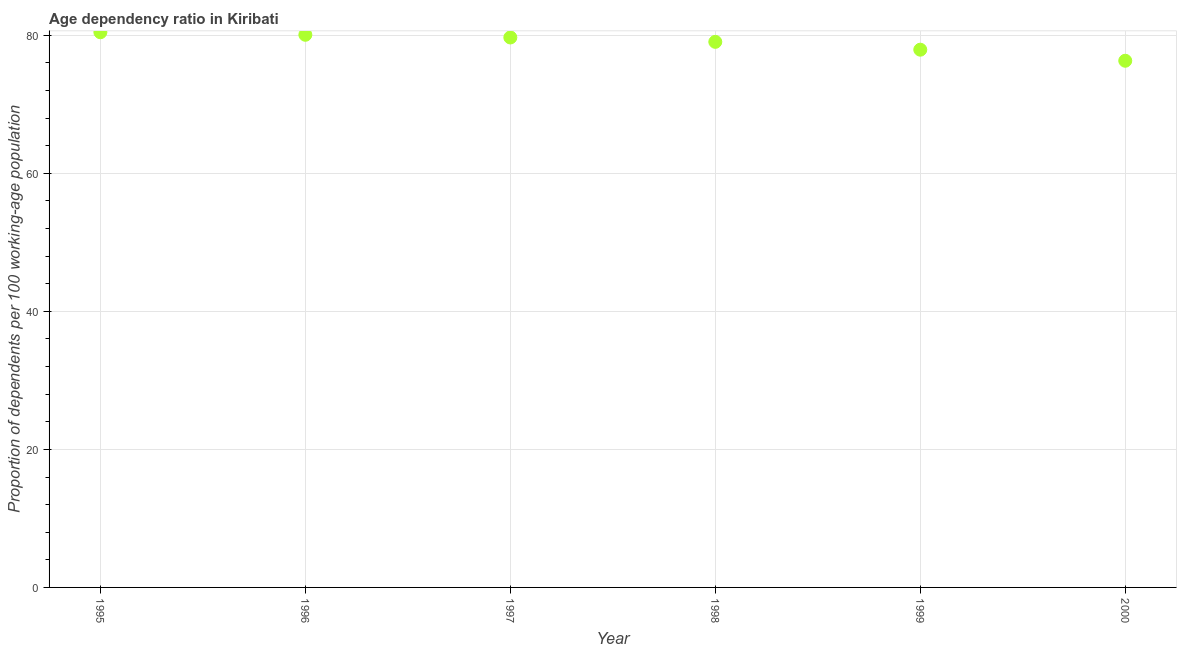What is the age dependency ratio in 1999?
Make the answer very short. 77.92. Across all years, what is the maximum age dependency ratio?
Give a very brief answer. 80.45. Across all years, what is the minimum age dependency ratio?
Provide a succinct answer. 76.32. In which year was the age dependency ratio maximum?
Make the answer very short. 1995. What is the sum of the age dependency ratio?
Offer a terse response. 473.5. What is the difference between the age dependency ratio in 1997 and 1998?
Provide a short and direct response. 0.63. What is the average age dependency ratio per year?
Offer a very short reply. 78.92. What is the median age dependency ratio?
Your response must be concise. 79.37. In how many years, is the age dependency ratio greater than 44 ?
Give a very brief answer. 6. What is the ratio of the age dependency ratio in 1995 to that in 1997?
Your response must be concise. 1.01. Is the age dependency ratio in 1997 less than that in 1998?
Your answer should be very brief. No. Is the difference between the age dependency ratio in 1997 and 2000 greater than the difference between any two years?
Provide a short and direct response. No. What is the difference between the highest and the second highest age dependency ratio?
Provide a succinct answer. 0.37. Is the sum of the age dependency ratio in 1997 and 1999 greater than the maximum age dependency ratio across all years?
Your answer should be very brief. Yes. What is the difference between the highest and the lowest age dependency ratio?
Your answer should be compact. 4.13. In how many years, is the age dependency ratio greater than the average age dependency ratio taken over all years?
Give a very brief answer. 4. What is the difference between two consecutive major ticks on the Y-axis?
Make the answer very short. 20. Are the values on the major ticks of Y-axis written in scientific E-notation?
Offer a terse response. No. What is the title of the graph?
Your response must be concise. Age dependency ratio in Kiribati. What is the label or title of the Y-axis?
Your response must be concise. Proportion of dependents per 100 working-age population. What is the Proportion of dependents per 100 working-age population in 1995?
Provide a short and direct response. 80.45. What is the Proportion of dependents per 100 working-age population in 1996?
Provide a short and direct response. 80.08. What is the Proportion of dependents per 100 working-age population in 1997?
Provide a succinct answer. 79.69. What is the Proportion of dependents per 100 working-age population in 1998?
Give a very brief answer. 79.06. What is the Proportion of dependents per 100 working-age population in 1999?
Provide a succinct answer. 77.92. What is the Proportion of dependents per 100 working-age population in 2000?
Keep it short and to the point. 76.32. What is the difference between the Proportion of dependents per 100 working-age population in 1995 and 1996?
Provide a short and direct response. 0.37. What is the difference between the Proportion of dependents per 100 working-age population in 1995 and 1997?
Give a very brief answer. 0.76. What is the difference between the Proportion of dependents per 100 working-age population in 1995 and 1998?
Offer a very short reply. 1.39. What is the difference between the Proportion of dependents per 100 working-age population in 1995 and 1999?
Give a very brief answer. 2.53. What is the difference between the Proportion of dependents per 100 working-age population in 1995 and 2000?
Your answer should be very brief. 4.13. What is the difference between the Proportion of dependents per 100 working-age population in 1996 and 1997?
Ensure brevity in your answer.  0.39. What is the difference between the Proportion of dependents per 100 working-age population in 1996 and 1998?
Your answer should be very brief. 1.02. What is the difference between the Proportion of dependents per 100 working-age population in 1996 and 1999?
Ensure brevity in your answer.  2.16. What is the difference between the Proportion of dependents per 100 working-age population in 1996 and 2000?
Make the answer very short. 3.76. What is the difference between the Proportion of dependents per 100 working-age population in 1997 and 1998?
Offer a terse response. 0.63. What is the difference between the Proportion of dependents per 100 working-age population in 1997 and 1999?
Offer a terse response. 1.77. What is the difference between the Proportion of dependents per 100 working-age population in 1997 and 2000?
Provide a succinct answer. 3.37. What is the difference between the Proportion of dependents per 100 working-age population in 1998 and 1999?
Offer a very short reply. 1.14. What is the difference between the Proportion of dependents per 100 working-age population in 1998 and 2000?
Offer a very short reply. 2.74. What is the difference between the Proportion of dependents per 100 working-age population in 1999 and 2000?
Give a very brief answer. 1.6. What is the ratio of the Proportion of dependents per 100 working-age population in 1995 to that in 1997?
Make the answer very short. 1.01. What is the ratio of the Proportion of dependents per 100 working-age population in 1995 to that in 1999?
Your answer should be compact. 1.03. What is the ratio of the Proportion of dependents per 100 working-age population in 1995 to that in 2000?
Provide a short and direct response. 1.05. What is the ratio of the Proportion of dependents per 100 working-age population in 1996 to that in 1998?
Your answer should be very brief. 1.01. What is the ratio of the Proportion of dependents per 100 working-age population in 1996 to that in 1999?
Your answer should be compact. 1.03. What is the ratio of the Proportion of dependents per 100 working-age population in 1996 to that in 2000?
Give a very brief answer. 1.05. What is the ratio of the Proportion of dependents per 100 working-age population in 1997 to that in 1998?
Ensure brevity in your answer.  1.01. What is the ratio of the Proportion of dependents per 100 working-age population in 1997 to that in 1999?
Offer a terse response. 1.02. What is the ratio of the Proportion of dependents per 100 working-age population in 1997 to that in 2000?
Provide a short and direct response. 1.04. What is the ratio of the Proportion of dependents per 100 working-age population in 1998 to that in 1999?
Offer a terse response. 1.01. What is the ratio of the Proportion of dependents per 100 working-age population in 1998 to that in 2000?
Ensure brevity in your answer.  1.04. What is the ratio of the Proportion of dependents per 100 working-age population in 1999 to that in 2000?
Ensure brevity in your answer.  1.02. 